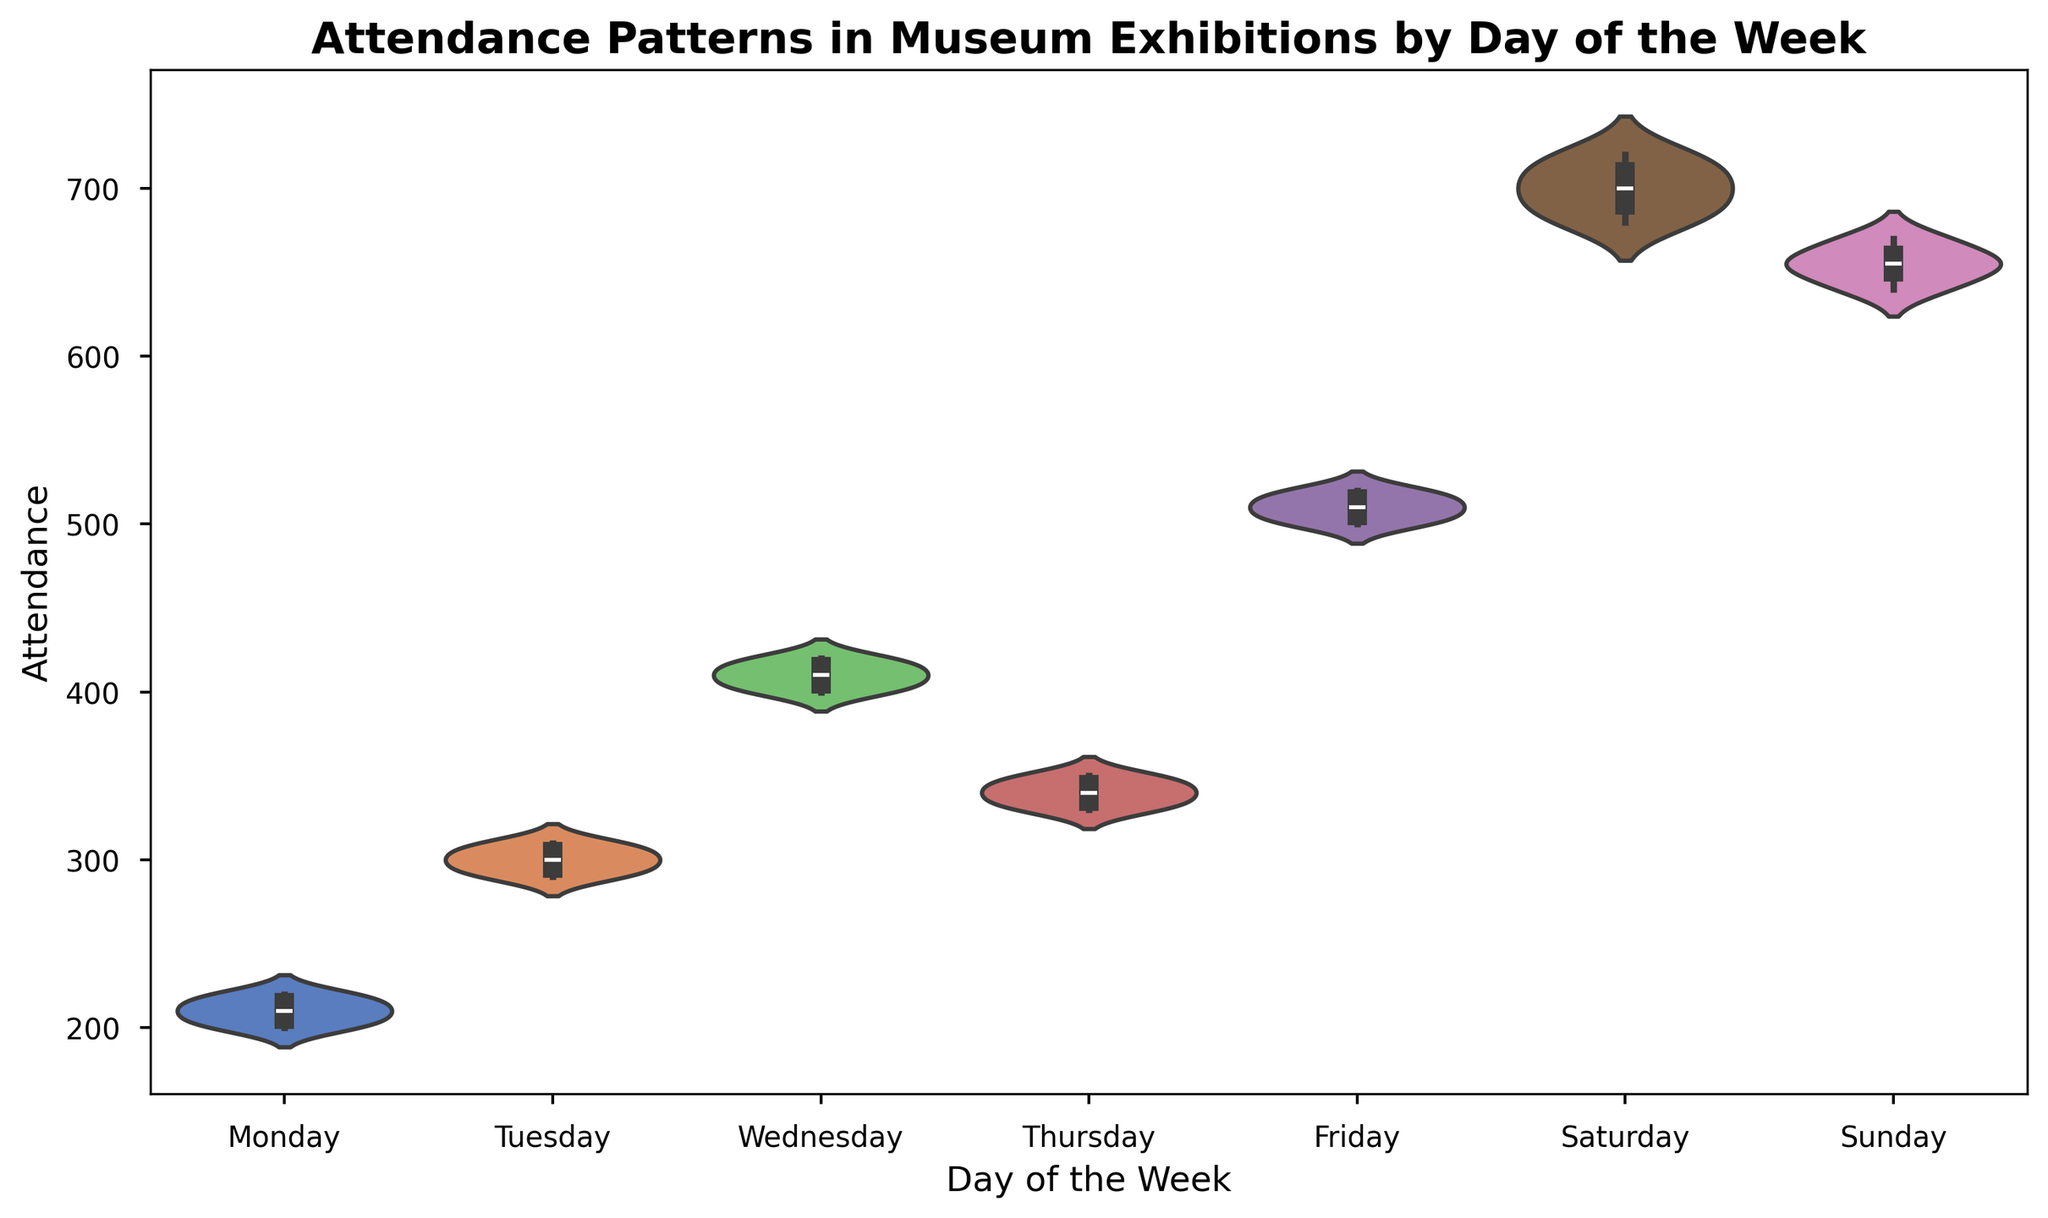What day of the week has the highest median attendance? To identify the median attendance, we need to look at the middle value of the distribution. From the violin plot, the day with the highest median attendance is Saturday.
Answer: Saturday Which day of the week shows the widest range of attendance values? The widest range of attendance values can be detected by identifying the length of the violin. The day with the widest range is Saturday.
Answer: Saturday Is the median attendance on Friday higher or lower than on Sunday? To compare the median attendance of Friday and Sunday, look at the midpoints of the violins. The median attendance on Friday is higher than on Sunday.
Answer: Higher Which day of the week has the most consistent attendance? The consistency can be determined by the width and spread of the violin plot. The narrowest violin indicates the most consistent attendance. The consistent day is Monday.
Answer: Monday List the days in descending order of median attendance. To list the days in descending order of median attendance, observe the midpoint of each violin plot. The order is Saturday, Sunday, Friday, Wednesday, Tuesday, Thursday, Monday.
Answer: Saturday, Sunday, Friday, Wednesday, Tuesday, Thursday, Monday On which day is there the greatest overlap in attendance values with Wednesday? The overlap in attendance can be evaluated by observing the similarity in ranges. Friday overlaps significantly with the range of attendance values for Wednesday.
Answer: Friday Which day shows the least variability in attendance and has a median of around 200? Least variability is indicated by a narrow violin plot, and a median close to 200 is observed on Monday.
Answer: Monday Are there more days with median attendance above or below 400? Identify the days with medians above and below 400 by looking at the central line in each violin plot. More days (4) have median attendance below 400 than those above (3).
Answer: Below What's the difference in median attendance between the day with the highest and lowest median attendance? The highest median attendance is on Saturday (~700), and the lowest is on Monday (~210). The difference is 700 - 210 = 490.
Answer: 490 